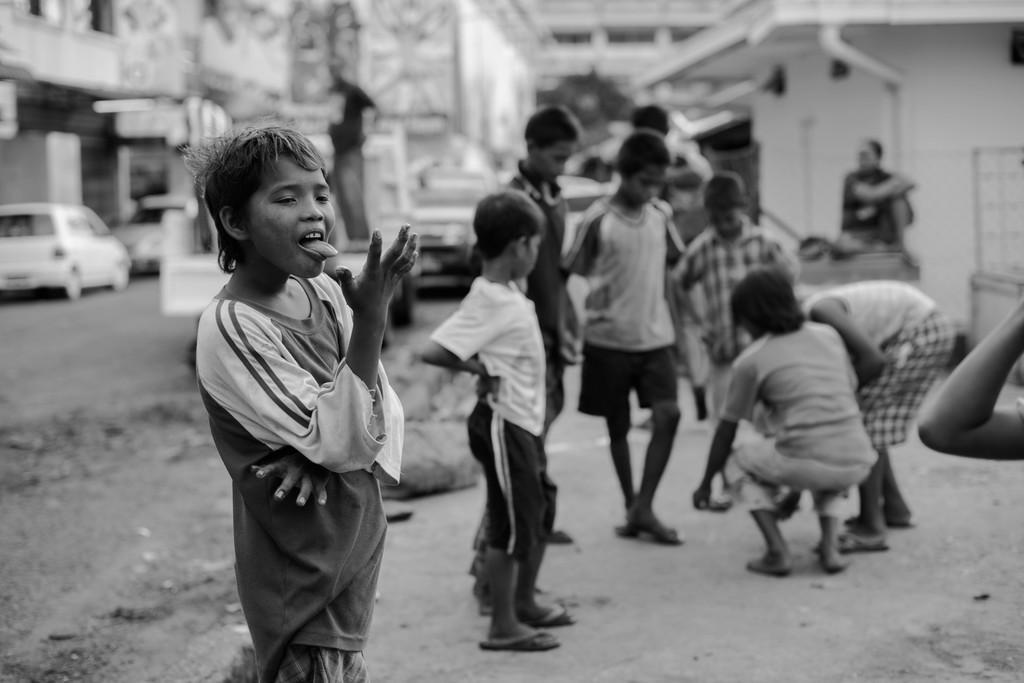In one or two sentences, can you explain what this image depicts? It is a black and white image, there are a group of children and the background of the children is blur. 